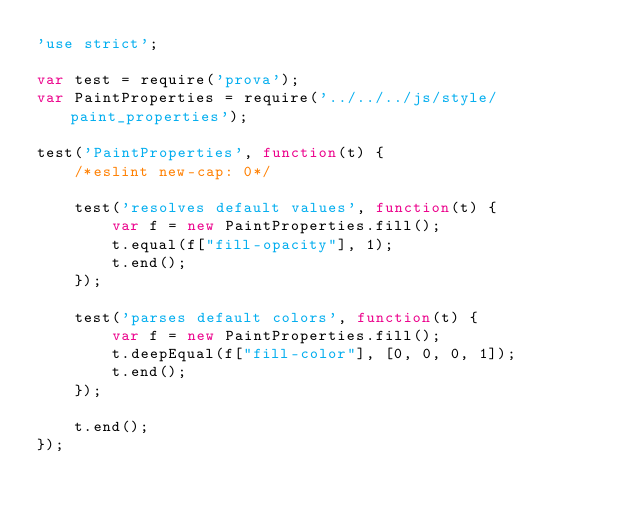<code> <loc_0><loc_0><loc_500><loc_500><_JavaScript_>'use strict';

var test = require('prova');
var PaintProperties = require('../../../js/style/paint_properties');

test('PaintProperties', function(t) {
    /*eslint new-cap: 0*/

    test('resolves default values', function(t) {
        var f = new PaintProperties.fill();
        t.equal(f["fill-opacity"], 1);
        t.end();
    });

    test('parses default colors', function(t) {
        var f = new PaintProperties.fill();
        t.deepEqual(f["fill-color"], [0, 0, 0, 1]);
        t.end();
    });

    t.end();
});
</code> 